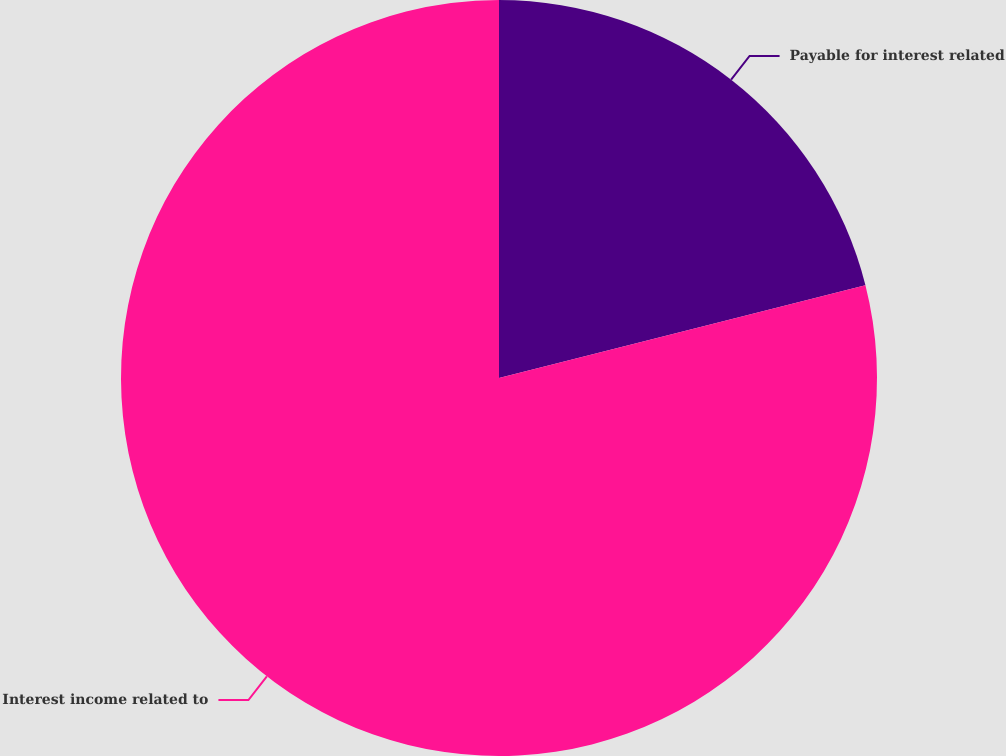Convert chart. <chart><loc_0><loc_0><loc_500><loc_500><pie_chart><fcel>Payable for interest related<fcel>Interest income related to<nl><fcel>21.05%<fcel>78.95%<nl></chart> 